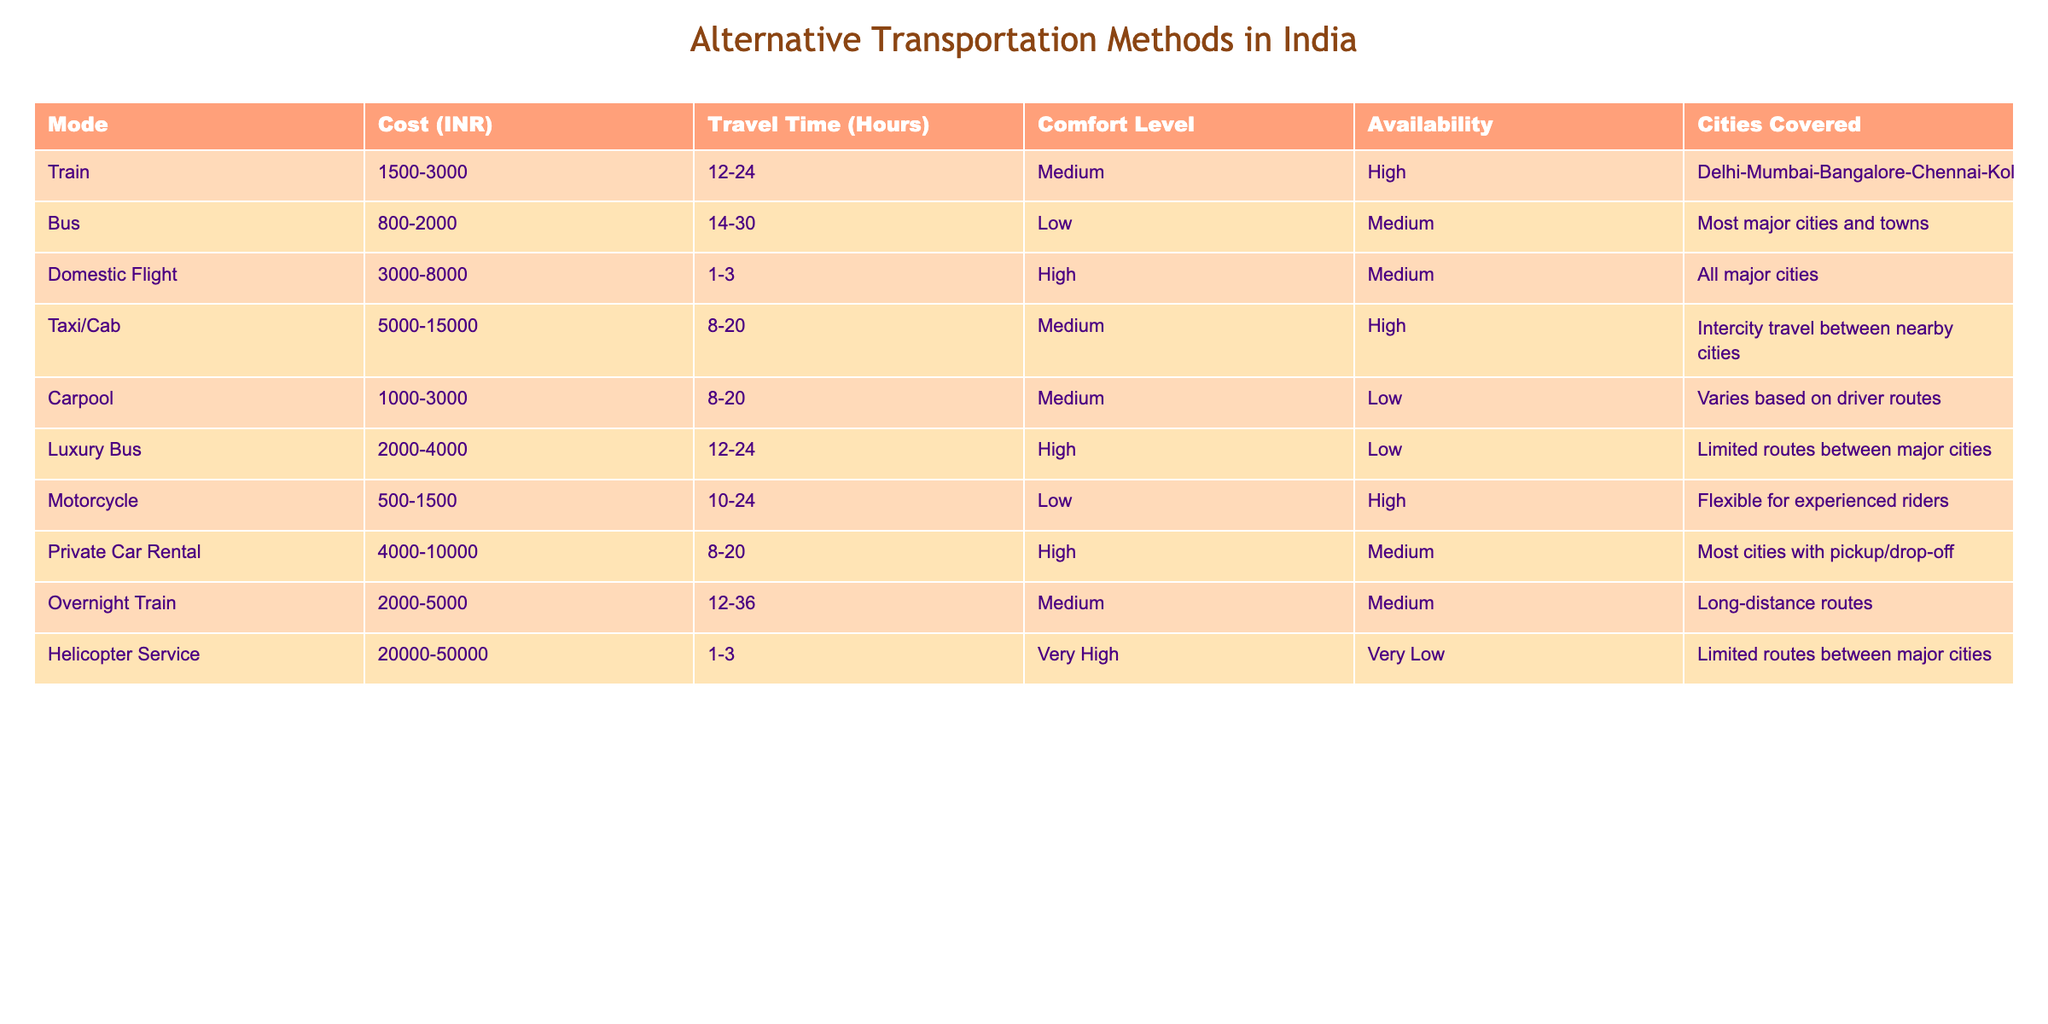What is the cost range for domestic flights? The cost range for domestic flights is explicitly mentioned in the table under the 'Cost (INR)' column. It shows that the cost is between 3000 to 8000 INR.
Answer: 3000-8000 INR Which mode of transportation has the highest comfort level? The comfort level for each mode is categorized in the 'Comfort Level' column. The domestic flight and helicopter service both have the highest rating of "High" and "Very High" respectively. However, the helicopter service has "Very High," making it the highest overall.
Answer: Helicopter Service Is the availability of luxury buses high or low? The availability is indicated in the 'Availability' column, where luxury buses are marked as having "Low" availability.
Answer: Low What is the average travel time for trains and overnight trains combined? The travel time ranges for trains are between 12-24 hours and for overnight trains between 12-36 hours. To find the averages: For trains, the average of (12 + 24) / 2 = 18 hours. For overnight trains, the average is (12 + 36) / 2 = 24 hours. Adding these gives a total of 42 hours. Dividing by 2 gives an average of 21 hours overall.
Answer: 21 hours Are motorcycles available for all major cities? In the 'Cities Covered' column, motorcycles are marked as "Flexible for experienced riders," indicating that their availability depends on the rider's route and is not universally applied to all major cities.
Answer: No What is the cost difference between the cheapest and the most expensive transport modes? To determine the cost difference, we take the lowest cost of the bus which is 800 INR and the highest cost of the helicopter service which is 50000 INR. The difference is 50000 - 800 = 49200 INR.
Answer: 49200 INR Is train travel faster than bus travel on average? The average travel times should be compared. For trains, the average time is (12 + 24) / 2 = 18 hours, and for bus travel, it is (14 + 30) / 2 = 22 hours. Since 18 hours is less than 22 hours, we conclude that train travel is indeed faster.
Answer: Yes Which transportation method covers Delhi, Mumbai, and Bangalore? Looking at the 'Cities Covered' column, domestic flights cover all major cities including Delhi, Mumbai, and Bangalore. Additionally, trains also cover these cities.
Answer: Domestic Flight and Train 